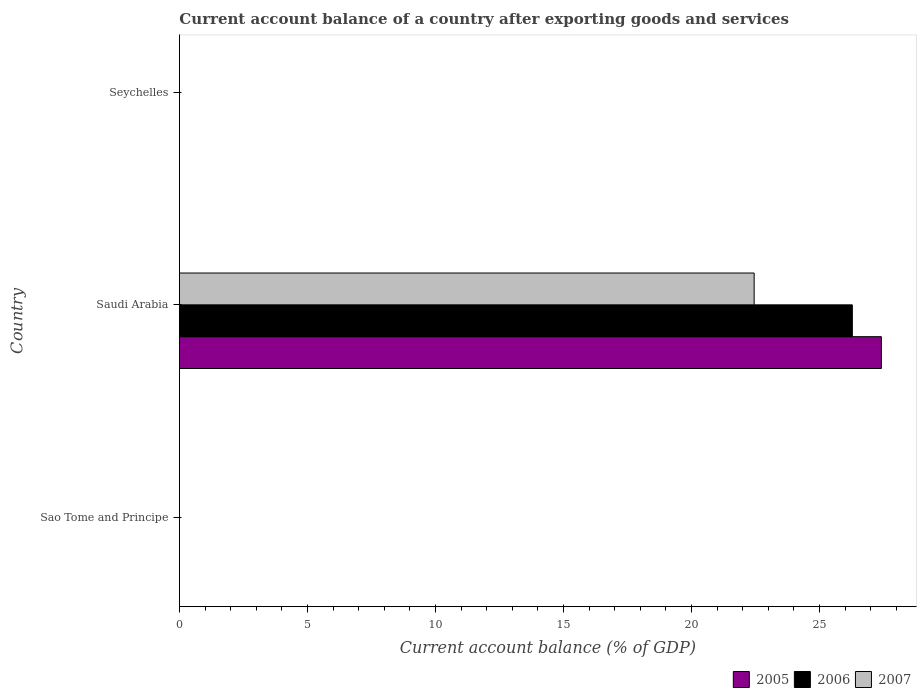How many different coloured bars are there?
Your response must be concise. 3. Are the number of bars per tick equal to the number of legend labels?
Make the answer very short. No. Are the number of bars on each tick of the Y-axis equal?
Offer a terse response. No. How many bars are there on the 1st tick from the top?
Keep it short and to the point. 0. What is the label of the 1st group of bars from the top?
Your answer should be compact. Seychelles. What is the account balance in 2007 in Saudi Arabia?
Give a very brief answer. 22.45. Across all countries, what is the maximum account balance in 2006?
Keep it short and to the point. 26.28. In which country was the account balance in 2005 maximum?
Offer a terse response. Saudi Arabia. What is the total account balance in 2005 in the graph?
Make the answer very short. 27.42. What is the difference between the account balance in 2007 in Saudi Arabia and the account balance in 2006 in Sao Tome and Principe?
Provide a succinct answer. 22.45. What is the average account balance in 2007 per country?
Offer a very short reply. 7.48. What is the difference between the account balance in 2005 and account balance in 2007 in Saudi Arabia?
Provide a succinct answer. 4.97. What is the difference between the highest and the lowest account balance in 2006?
Provide a short and direct response. 26.28. What is the difference between two consecutive major ticks on the X-axis?
Your answer should be compact. 5. Are the values on the major ticks of X-axis written in scientific E-notation?
Provide a short and direct response. No. Does the graph contain any zero values?
Your answer should be compact. Yes. Where does the legend appear in the graph?
Your answer should be compact. Bottom right. How many legend labels are there?
Provide a short and direct response. 3. How are the legend labels stacked?
Provide a succinct answer. Horizontal. What is the title of the graph?
Give a very brief answer. Current account balance of a country after exporting goods and services. What is the label or title of the X-axis?
Your answer should be very brief. Current account balance (% of GDP). What is the label or title of the Y-axis?
Keep it short and to the point. Country. What is the Current account balance (% of GDP) of 2006 in Sao Tome and Principe?
Provide a succinct answer. 0. What is the Current account balance (% of GDP) in 2005 in Saudi Arabia?
Your answer should be compact. 27.42. What is the Current account balance (% of GDP) of 2006 in Saudi Arabia?
Give a very brief answer. 26.28. What is the Current account balance (% of GDP) in 2007 in Saudi Arabia?
Offer a terse response. 22.45. What is the Current account balance (% of GDP) in 2005 in Seychelles?
Offer a very short reply. 0. What is the Current account balance (% of GDP) in 2007 in Seychelles?
Your answer should be compact. 0. Across all countries, what is the maximum Current account balance (% of GDP) of 2005?
Your response must be concise. 27.42. Across all countries, what is the maximum Current account balance (% of GDP) of 2006?
Your answer should be compact. 26.28. Across all countries, what is the maximum Current account balance (% of GDP) in 2007?
Offer a very short reply. 22.45. Across all countries, what is the minimum Current account balance (% of GDP) of 2005?
Make the answer very short. 0. Across all countries, what is the minimum Current account balance (% of GDP) of 2007?
Give a very brief answer. 0. What is the total Current account balance (% of GDP) in 2005 in the graph?
Give a very brief answer. 27.42. What is the total Current account balance (% of GDP) of 2006 in the graph?
Your answer should be compact. 26.28. What is the total Current account balance (% of GDP) of 2007 in the graph?
Ensure brevity in your answer.  22.45. What is the average Current account balance (% of GDP) of 2005 per country?
Make the answer very short. 9.14. What is the average Current account balance (% of GDP) in 2006 per country?
Provide a short and direct response. 8.76. What is the average Current account balance (% of GDP) in 2007 per country?
Your answer should be very brief. 7.48. What is the difference between the Current account balance (% of GDP) in 2005 and Current account balance (% of GDP) in 2006 in Saudi Arabia?
Keep it short and to the point. 1.13. What is the difference between the Current account balance (% of GDP) in 2005 and Current account balance (% of GDP) in 2007 in Saudi Arabia?
Give a very brief answer. 4.97. What is the difference between the Current account balance (% of GDP) in 2006 and Current account balance (% of GDP) in 2007 in Saudi Arabia?
Your response must be concise. 3.84. What is the difference between the highest and the lowest Current account balance (% of GDP) in 2005?
Your answer should be compact. 27.42. What is the difference between the highest and the lowest Current account balance (% of GDP) of 2006?
Give a very brief answer. 26.28. What is the difference between the highest and the lowest Current account balance (% of GDP) of 2007?
Make the answer very short. 22.45. 